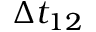<formula> <loc_0><loc_0><loc_500><loc_500>\Delta t _ { 1 2 }</formula> 